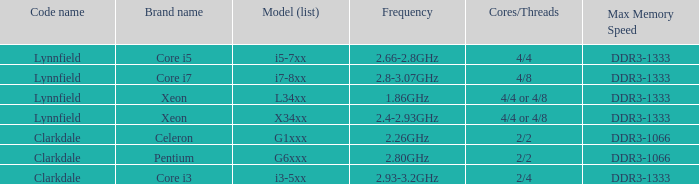93- DDR3-1333. 